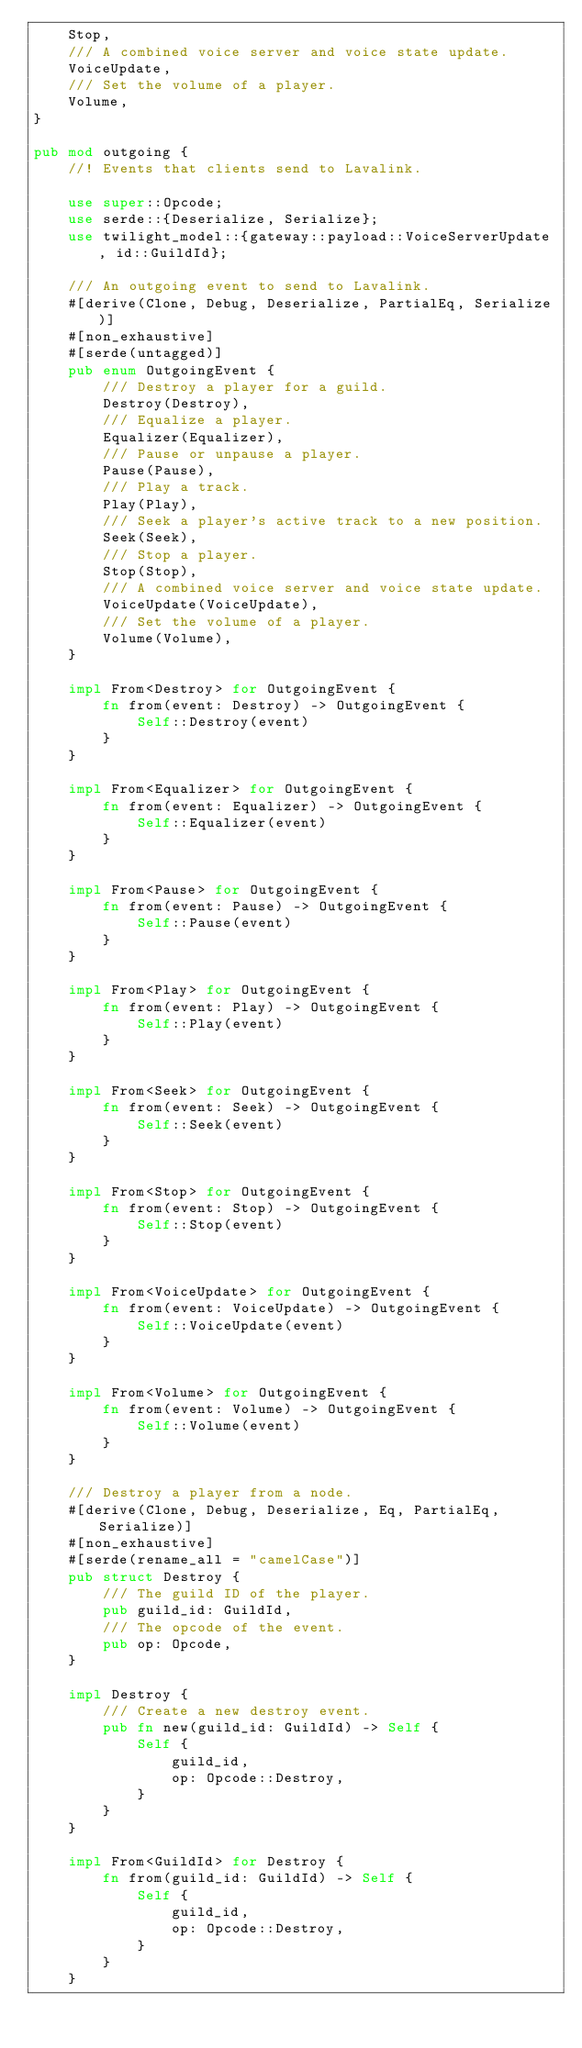Convert code to text. <code><loc_0><loc_0><loc_500><loc_500><_Rust_>    Stop,
    /// A combined voice server and voice state update.
    VoiceUpdate,
    /// Set the volume of a player.
    Volume,
}

pub mod outgoing {
    //! Events that clients send to Lavalink.

    use super::Opcode;
    use serde::{Deserialize, Serialize};
    use twilight_model::{gateway::payload::VoiceServerUpdate, id::GuildId};

    /// An outgoing event to send to Lavalink.
    #[derive(Clone, Debug, Deserialize, PartialEq, Serialize)]
    #[non_exhaustive]
    #[serde(untagged)]
    pub enum OutgoingEvent {
        /// Destroy a player for a guild.
        Destroy(Destroy),
        /// Equalize a player.
        Equalizer(Equalizer),
        /// Pause or unpause a player.
        Pause(Pause),
        /// Play a track.
        Play(Play),
        /// Seek a player's active track to a new position.
        Seek(Seek),
        /// Stop a player.
        Stop(Stop),
        /// A combined voice server and voice state update.
        VoiceUpdate(VoiceUpdate),
        /// Set the volume of a player.
        Volume(Volume),
    }

    impl From<Destroy> for OutgoingEvent {
        fn from(event: Destroy) -> OutgoingEvent {
            Self::Destroy(event)
        }
    }

    impl From<Equalizer> for OutgoingEvent {
        fn from(event: Equalizer) -> OutgoingEvent {
            Self::Equalizer(event)
        }
    }

    impl From<Pause> for OutgoingEvent {
        fn from(event: Pause) -> OutgoingEvent {
            Self::Pause(event)
        }
    }

    impl From<Play> for OutgoingEvent {
        fn from(event: Play) -> OutgoingEvent {
            Self::Play(event)
        }
    }

    impl From<Seek> for OutgoingEvent {
        fn from(event: Seek) -> OutgoingEvent {
            Self::Seek(event)
        }
    }

    impl From<Stop> for OutgoingEvent {
        fn from(event: Stop) -> OutgoingEvent {
            Self::Stop(event)
        }
    }

    impl From<VoiceUpdate> for OutgoingEvent {
        fn from(event: VoiceUpdate) -> OutgoingEvent {
            Self::VoiceUpdate(event)
        }
    }

    impl From<Volume> for OutgoingEvent {
        fn from(event: Volume) -> OutgoingEvent {
            Self::Volume(event)
        }
    }

    /// Destroy a player from a node.
    #[derive(Clone, Debug, Deserialize, Eq, PartialEq, Serialize)]
    #[non_exhaustive]
    #[serde(rename_all = "camelCase")]
    pub struct Destroy {
        /// The guild ID of the player.
        pub guild_id: GuildId,
        /// The opcode of the event.
        pub op: Opcode,
    }

    impl Destroy {
        /// Create a new destroy event.
        pub fn new(guild_id: GuildId) -> Self {
            Self {
                guild_id,
                op: Opcode::Destroy,
            }
        }
    }

    impl From<GuildId> for Destroy {
        fn from(guild_id: GuildId) -> Self {
            Self {
                guild_id,
                op: Opcode::Destroy,
            }
        }
    }
</code> 